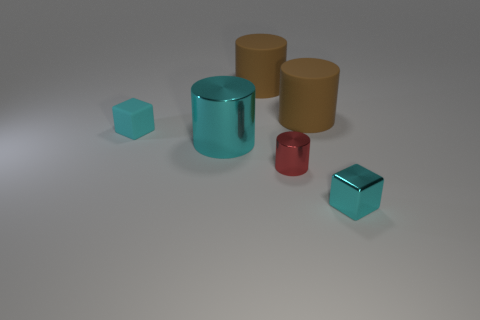There is another cyan block that is the same size as the cyan rubber cube; what material is it? Based on the image, the other cyan block that shares the same size with the cyan rubber cube appears to be made of metal due to its reflective surface and distinct sheen compared to the less reflective and more matte finish of the rubber cube. 